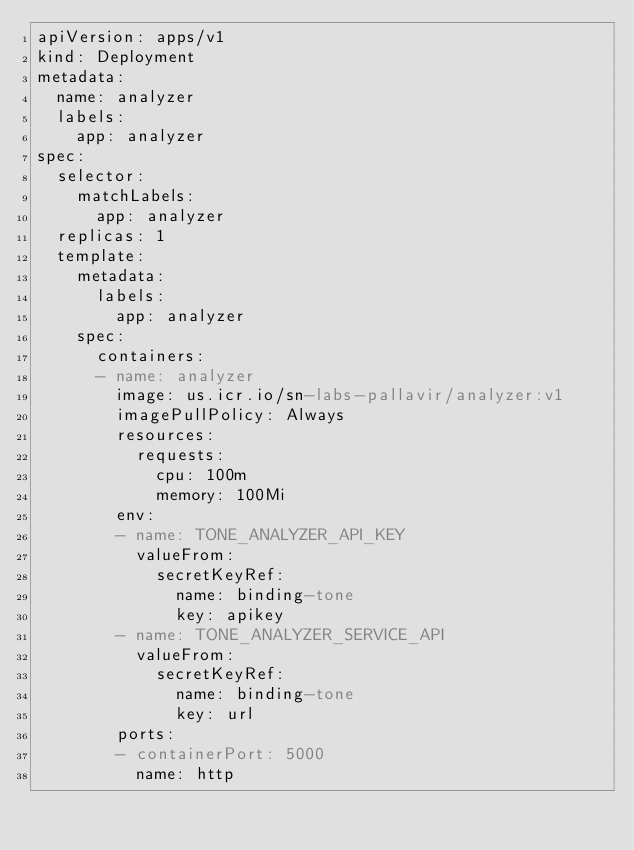Convert code to text. <code><loc_0><loc_0><loc_500><loc_500><_YAML_>apiVersion: apps/v1
kind: Deployment
metadata:
  name: analyzer
  labels:
    app: analyzer
spec:
  selector:
    matchLabels:
      app: analyzer
  replicas: 1
  template:
    metadata:
      labels:
        app: analyzer
    spec:
      containers:
      - name: analyzer
        image: us.icr.io/sn-labs-pallavir/analyzer:v1
        imagePullPolicy: Always
        resources:
          requests:
            cpu: 100m
            memory: 100Mi
        env:
        - name: TONE_ANALYZER_API_KEY
          valueFrom:
            secretKeyRef:
              name: binding-tone
              key: apikey
        - name: TONE_ANALYZER_SERVICE_API
          valueFrom:
            secretKeyRef:
              name: binding-tone
              key: url
        ports:
        - containerPort: 5000
          name: http
</code> 